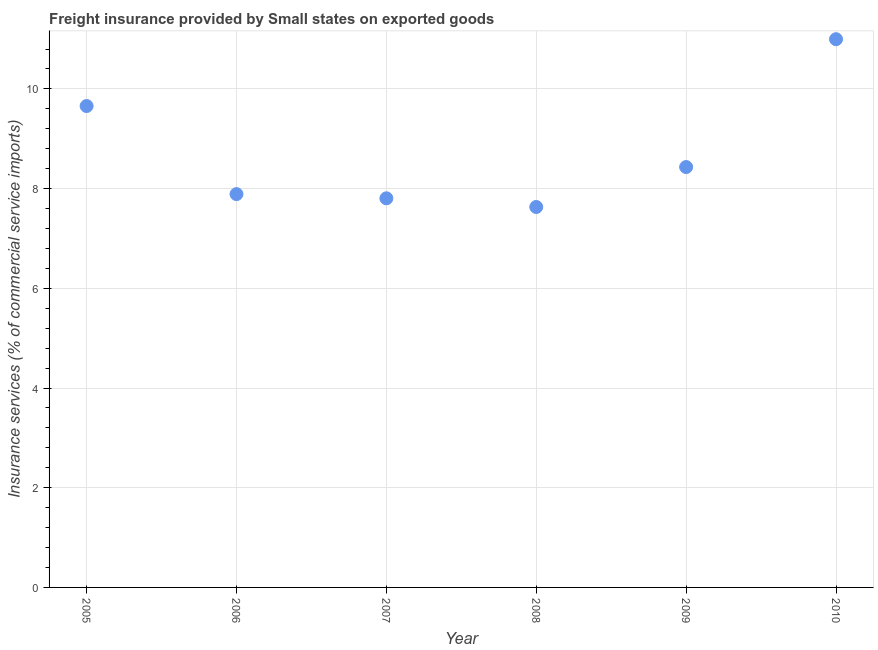What is the freight insurance in 2009?
Provide a succinct answer. 8.43. Across all years, what is the maximum freight insurance?
Give a very brief answer. 11. Across all years, what is the minimum freight insurance?
Offer a very short reply. 7.63. In which year was the freight insurance maximum?
Make the answer very short. 2010. What is the sum of the freight insurance?
Offer a terse response. 52.41. What is the difference between the freight insurance in 2005 and 2009?
Your response must be concise. 1.22. What is the average freight insurance per year?
Ensure brevity in your answer.  8.74. What is the median freight insurance?
Provide a short and direct response. 8.16. In how many years, is the freight insurance greater than 2.8 %?
Offer a very short reply. 6. Do a majority of the years between 2007 and 2010 (inclusive) have freight insurance greater than 8 %?
Your answer should be very brief. No. What is the ratio of the freight insurance in 2006 to that in 2007?
Offer a terse response. 1.01. Is the freight insurance in 2008 less than that in 2010?
Keep it short and to the point. Yes. What is the difference between the highest and the second highest freight insurance?
Your answer should be compact. 1.34. Is the sum of the freight insurance in 2005 and 2006 greater than the maximum freight insurance across all years?
Keep it short and to the point. Yes. What is the difference between the highest and the lowest freight insurance?
Offer a very short reply. 3.37. How many dotlines are there?
Your response must be concise. 1. Are the values on the major ticks of Y-axis written in scientific E-notation?
Your answer should be compact. No. Does the graph contain any zero values?
Keep it short and to the point. No. What is the title of the graph?
Offer a terse response. Freight insurance provided by Small states on exported goods . What is the label or title of the X-axis?
Your answer should be very brief. Year. What is the label or title of the Y-axis?
Ensure brevity in your answer.  Insurance services (% of commercial service imports). What is the Insurance services (% of commercial service imports) in 2005?
Ensure brevity in your answer.  9.66. What is the Insurance services (% of commercial service imports) in 2006?
Ensure brevity in your answer.  7.89. What is the Insurance services (% of commercial service imports) in 2007?
Provide a short and direct response. 7.81. What is the Insurance services (% of commercial service imports) in 2008?
Offer a terse response. 7.63. What is the Insurance services (% of commercial service imports) in 2009?
Make the answer very short. 8.43. What is the Insurance services (% of commercial service imports) in 2010?
Your answer should be very brief. 11. What is the difference between the Insurance services (% of commercial service imports) in 2005 and 2006?
Offer a terse response. 1.77. What is the difference between the Insurance services (% of commercial service imports) in 2005 and 2007?
Give a very brief answer. 1.85. What is the difference between the Insurance services (% of commercial service imports) in 2005 and 2008?
Your response must be concise. 2.03. What is the difference between the Insurance services (% of commercial service imports) in 2005 and 2009?
Make the answer very short. 1.22. What is the difference between the Insurance services (% of commercial service imports) in 2005 and 2010?
Provide a succinct answer. -1.34. What is the difference between the Insurance services (% of commercial service imports) in 2006 and 2007?
Keep it short and to the point. 0.08. What is the difference between the Insurance services (% of commercial service imports) in 2006 and 2008?
Offer a very short reply. 0.26. What is the difference between the Insurance services (% of commercial service imports) in 2006 and 2009?
Give a very brief answer. -0.54. What is the difference between the Insurance services (% of commercial service imports) in 2006 and 2010?
Provide a succinct answer. -3.11. What is the difference between the Insurance services (% of commercial service imports) in 2007 and 2008?
Provide a succinct answer. 0.17. What is the difference between the Insurance services (% of commercial service imports) in 2007 and 2009?
Give a very brief answer. -0.63. What is the difference between the Insurance services (% of commercial service imports) in 2007 and 2010?
Offer a very short reply. -3.19. What is the difference between the Insurance services (% of commercial service imports) in 2008 and 2009?
Offer a very short reply. -0.8. What is the difference between the Insurance services (% of commercial service imports) in 2008 and 2010?
Give a very brief answer. -3.37. What is the difference between the Insurance services (% of commercial service imports) in 2009 and 2010?
Your answer should be very brief. -2.56. What is the ratio of the Insurance services (% of commercial service imports) in 2005 to that in 2006?
Your response must be concise. 1.22. What is the ratio of the Insurance services (% of commercial service imports) in 2005 to that in 2007?
Ensure brevity in your answer.  1.24. What is the ratio of the Insurance services (% of commercial service imports) in 2005 to that in 2008?
Give a very brief answer. 1.26. What is the ratio of the Insurance services (% of commercial service imports) in 2005 to that in 2009?
Provide a succinct answer. 1.15. What is the ratio of the Insurance services (% of commercial service imports) in 2005 to that in 2010?
Offer a very short reply. 0.88. What is the ratio of the Insurance services (% of commercial service imports) in 2006 to that in 2008?
Keep it short and to the point. 1.03. What is the ratio of the Insurance services (% of commercial service imports) in 2006 to that in 2009?
Your answer should be compact. 0.94. What is the ratio of the Insurance services (% of commercial service imports) in 2006 to that in 2010?
Your answer should be very brief. 0.72. What is the ratio of the Insurance services (% of commercial service imports) in 2007 to that in 2008?
Your answer should be compact. 1.02. What is the ratio of the Insurance services (% of commercial service imports) in 2007 to that in 2009?
Ensure brevity in your answer.  0.93. What is the ratio of the Insurance services (% of commercial service imports) in 2007 to that in 2010?
Give a very brief answer. 0.71. What is the ratio of the Insurance services (% of commercial service imports) in 2008 to that in 2009?
Offer a very short reply. 0.91. What is the ratio of the Insurance services (% of commercial service imports) in 2008 to that in 2010?
Your answer should be very brief. 0.69. What is the ratio of the Insurance services (% of commercial service imports) in 2009 to that in 2010?
Give a very brief answer. 0.77. 